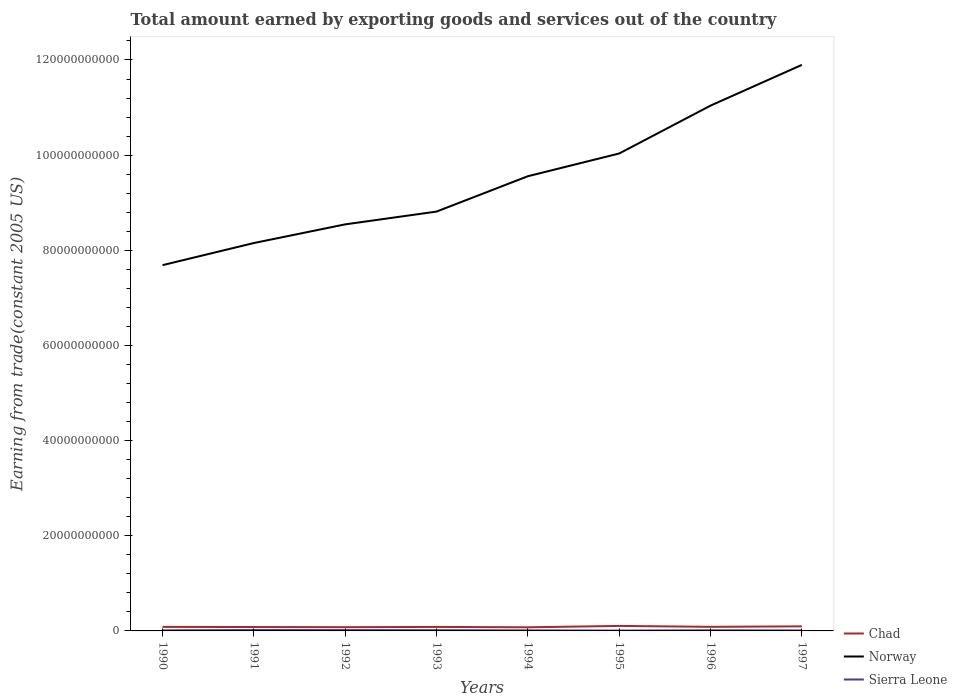Does the line corresponding to Sierra Leone intersect with the line corresponding to Chad?
Provide a short and direct response. No. Across all years, what is the maximum total amount earned by exporting goods and services in Sierra Leone?
Your answer should be compact. 7.47e+07. In which year was the total amount earned by exporting goods and services in Norway maximum?
Ensure brevity in your answer.  1990. What is the total total amount earned by exporting goods and services in Sierra Leone in the graph?
Provide a short and direct response. 5.59e+07. What is the difference between the highest and the second highest total amount earned by exporting goods and services in Sierra Leone?
Your answer should be compact. 1.14e+08. Is the total amount earned by exporting goods and services in Sierra Leone strictly greater than the total amount earned by exporting goods and services in Chad over the years?
Provide a succinct answer. Yes. How many lines are there?
Offer a very short reply. 3. How many years are there in the graph?
Make the answer very short. 8. Does the graph contain any zero values?
Your answer should be very brief. No. Does the graph contain grids?
Provide a short and direct response. No. How are the legend labels stacked?
Your answer should be very brief. Vertical. What is the title of the graph?
Make the answer very short. Total amount earned by exporting goods and services out of the country. What is the label or title of the Y-axis?
Provide a short and direct response. Earning from trade(constant 2005 US). What is the Earning from trade(constant 2005 US) of Chad in 1990?
Ensure brevity in your answer.  8.47e+08. What is the Earning from trade(constant 2005 US) of Norway in 1990?
Keep it short and to the point. 7.69e+1. What is the Earning from trade(constant 2005 US) of Sierra Leone in 1990?
Your answer should be compact. 1.25e+08. What is the Earning from trade(constant 2005 US) in Chad in 1991?
Your response must be concise. 8.17e+08. What is the Earning from trade(constant 2005 US) of Norway in 1991?
Your answer should be very brief. 8.15e+1. What is the Earning from trade(constant 2005 US) in Sierra Leone in 1991?
Make the answer very short. 1.88e+08. What is the Earning from trade(constant 2005 US) of Chad in 1992?
Your response must be concise. 7.85e+08. What is the Earning from trade(constant 2005 US) of Norway in 1992?
Offer a terse response. 8.54e+1. What is the Earning from trade(constant 2005 US) of Sierra Leone in 1992?
Ensure brevity in your answer.  1.77e+08. What is the Earning from trade(constant 2005 US) in Chad in 1993?
Your answer should be compact. 8.40e+08. What is the Earning from trade(constant 2005 US) of Norway in 1993?
Give a very brief answer. 8.81e+1. What is the Earning from trade(constant 2005 US) in Sierra Leone in 1993?
Your response must be concise. 1.53e+08. What is the Earning from trade(constant 2005 US) in Chad in 1994?
Keep it short and to the point. 7.63e+08. What is the Earning from trade(constant 2005 US) of Norway in 1994?
Make the answer very short. 9.56e+1. What is the Earning from trade(constant 2005 US) of Sierra Leone in 1994?
Keep it short and to the point. 1.17e+08. What is the Earning from trade(constant 2005 US) of Chad in 1995?
Give a very brief answer. 1.05e+09. What is the Earning from trade(constant 2005 US) of Norway in 1995?
Offer a terse response. 1.00e+11. What is the Earning from trade(constant 2005 US) of Sierra Leone in 1995?
Offer a terse response. 7.47e+07. What is the Earning from trade(constant 2005 US) in Chad in 1996?
Keep it short and to the point. 8.60e+08. What is the Earning from trade(constant 2005 US) of Norway in 1996?
Your response must be concise. 1.10e+11. What is the Earning from trade(constant 2005 US) of Sierra Leone in 1996?
Ensure brevity in your answer.  1.32e+08. What is the Earning from trade(constant 2005 US) of Chad in 1997?
Offer a terse response. 9.61e+08. What is the Earning from trade(constant 2005 US) of Norway in 1997?
Provide a short and direct response. 1.19e+11. What is the Earning from trade(constant 2005 US) in Sierra Leone in 1997?
Ensure brevity in your answer.  9.75e+07. Across all years, what is the maximum Earning from trade(constant 2005 US) of Chad?
Make the answer very short. 1.05e+09. Across all years, what is the maximum Earning from trade(constant 2005 US) of Norway?
Provide a succinct answer. 1.19e+11. Across all years, what is the maximum Earning from trade(constant 2005 US) in Sierra Leone?
Keep it short and to the point. 1.88e+08. Across all years, what is the minimum Earning from trade(constant 2005 US) in Chad?
Offer a very short reply. 7.63e+08. Across all years, what is the minimum Earning from trade(constant 2005 US) in Norway?
Offer a very short reply. 7.69e+1. Across all years, what is the minimum Earning from trade(constant 2005 US) in Sierra Leone?
Offer a very short reply. 7.47e+07. What is the total Earning from trade(constant 2005 US) in Chad in the graph?
Your answer should be very brief. 6.92e+09. What is the total Earning from trade(constant 2005 US) of Norway in the graph?
Your answer should be compact. 7.57e+11. What is the total Earning from trade(constant 2005 US) of Sierra Leone in the graph?
Keep it short and to the point. 1.06e+09. What is the difference between the Earning from trade(constant 2005 US) of Chad in 1990 and that in 1991?
Your answer should be very brief. 3.00e+07. What is the difference between the Earning from trade(constant 2005 US) in Norway in 1990 and that in 1991?
Ensure brevity in your answer.  -4.65e+09. What is the difference between the Earning from trade(constant 2005 US) in Sierra Leone in 1990 and that in 1991?
Offer a terse response. -6.33e+07. What is the difference between the Earning from trade(constant 2005 US) of Chad in 1990 and that in 1992?
Your answer should be compact. 6.13e+07. What is the difference between the Earning from trade(constant 2005 US) in Norway in 1990 and that in 1992?
Your response must be concise. -8.57e+09. What is the difference between the Earning from trade(constant 2005 US) of Sierra Leone in 1990 and that in 1992?
Make the answer very short. -5.21e+07. What is the difference between the Earning from trade(constant 2005 US) in Chad in 1990 and that in 1993?
Offer a very short reply. 7.17e+06. What is the difference between the Earning from trade(constant 2005 US) of Norway in 1990 and that in 1993?
Keep it short and to the point. -1.13e+1. What is the difference between the Earning from trade(constant 2005 US) of Sierra Leone in 1990 and that in 1993?
Your answer should be very brief. -2.84e+07. What is the difference between the Earning from trade(constant 2005 US) in Chad in 1990 and that in 1994?
Ensure brevity in your answer.  8.37e+07. What is the difference between the Earning from trade(constant 2005 US) in Norway in 1990 and that in 1994?
Offer a terse response. -1.87e+1. What is the difference between the Earning from trade(constant 2005 US) in Sierra Leone in 1990 and that in 1994?
Offer a very short reply. 8.15e+06. What is the difference between the Earning from trade(constant 2005 US) of Chad in 1990 and that in 1995?
Your answer should be very brief. -2.05e+08. What is the difference between the Earning from trade(constant 2005 US) in Norway in 1990 and that in 1995?
Offer a terse response. -2.35e+1. What is the difference between the Earning from trade(constant 2005 US) of Sierra Leone in 1990 and that in 1995?
Ensure brevity in your answer.  5.03e+07. What is the difference between the Earning from trade(constant 2005 US) of Chad in 1990 and that in 1996?
Your answer should be very brief. -1.34e+07. What is the difference between the Earning from trade(constant 2005 US) of Norway in 1990 and that in 1996?
Offer a very short reply. -3.35e+1. What is the difference between the Earning from trade(constant 2005 US) of Sierra Leone in 1990 and that in 1996?
Your answer should be compact. -6.70e+06. What is the difference between the Earning from trade(constant 2005 US) of Chad in 1990 and that in 1997?
Give a very brief answer. -1.14e+08. What is the difference between the Earning from trade(constant 2005 US) of Norway in 1990 and that in 1997?
Give a very brief answer. -4.21e+1. What is the difference between the Earning from trade(constant 2005 US) of Sierra Leone in 1990 and that in 1997?
Your answer should be very brief. 2.75e+07. What is the difference between the Earning from trade(constant 2005 US) of Chad in 1991 and that in 1992?
Provide a short and direct response. 3.13e+07. What is the difference between the Earning from trade(constant 2005 US) in Norway in 1991 and that in 1992?
Provide a succinct answer. -3.92e+09. What is the difference between the Earning from trade(constant 2005 US) in Sierra Leone in 1991 and that in 1992?
Make the answer very short. 1.12e+07. What is the difference between the Earning from trade(constant 2005 US) of Chad in 1991 and that in 1993?
Give a very brief answer. -2.28e+07. What is the difference between the Earning from trade(constant 2005 US) in Norway in 1991 and that in 1993?
Ensure brevity in your answer.  -6.61e+09. What is the difference between the Earning from trade(constant 2005 US) of Sierra Leone in 1991 and that in 1993?
Provide a succinct answer. 3.49e+07. What is the difference between the Earning from trade(constant 2005 US) of Chad in 1991 and that in 1994?
Keep it short and to the point. 5.37e+07. What is the difference between the Earning from trade(constant 2005 US) of Norway in 1991 and that in 1994?
Offer a very short reply. -1.40e+1. What is the difference between the Earning from trade(constant 2005 US) of Sierra Leone in 1991 and that in 1994?
Offer a very short reply. 7.15e+07. What is the difference between the Earning from trade(constant 2005 US) in Chad in 1991 and that in 1995?
Offer a terse response. -2.35e+08. What is the difference between the Earning from trade(constant 2005 US) of Norway in 1991 and that in 1995?
Provide a succinct answer. -1.88e+1. What is the difference between the Earning from trade(constant 2005 US) of Sierra Leone in 1991 and that in 1995?
Give a very brief answer. 1.14e+08. What is the difference between the Earning from trade(constant 2005 US) of Chad in 1991 and that in 1996?
Your answer should be very brief. -4.34e+07. What is the difference between the Earning from trade(constant 2005 US) of Norway in 1991 and that in 1996?
Your answer should be very brief. -2.89e+1. What is the difference between the Earning from trade(constant 2005 US) in Sierra Leone in 1991 and that in 1996?
Your response must be concise. 5.66e+07. What is the difference between the Earning from trade(constant 2005 US) in Chad in 1991 and that in 1997?
Offer a terse response. -1.44e+08. What is the difference between the Earning from trade(constant 2005 US) in Norway in 1991 and that in 1997?
Your answer should be very brief. -3.74e+1. What is the difference between the Earning from trade(constant 2005 US) of Sierra Leone in 1991 and that in 1997?
Give a very brief answer. 9.08e+07. What is the difference between the Earning from trade(constant 2005 US) of Chad in 1992 and that in 1993?
Keep it short and to the point. -5.41e+07. What is the difference between the Earning from trade(constant 2005 US) of Norway in 1992 and that in 1993?
Offer a terse response. -2.69e+09. What is the difference between the Earning from trade(constant 2005 US) of Sierra Leone in 1992 and that in 1993?
Give a very brief answer. 2.37e+07. What is the difference between the Earning from trade(constant 2005 US) of Chad in 1992 and that in 1994?
Offer a terse response. 2.24e+07. What is the difference between the Earning from trade(constant 2005 US) of Norway in 1992 and that in 1994?
Keep it short and to the point. -1.01e+1. What is the difference between the Earning from trade(constant 2005 US) in Sierra Leone in 1992 and that in 1994?
Give a very brief answer. 6.02e+07. What is the difference between the Earning from trade(constant 2005 US) in Chad in 1992 and that in 1995?
Offer a very short reply. -2.66e+08. What is the difference between the Earning from trade(constant 2005 US) of Norway in 1992 and that in 1995?
Your response must be concise. -1.49e+1. What is the difference between the Earning from trade(constant 2005 US) of Sierra Leone in 1992 and that in 1995?
Give a very brief answer. 1.02e+08. What is the difference between the Earning from trade(constant 2005 US) in Chad in 1992 and that in 1996?
Provide a succinct answer. -7.46e+07. What is the difference between the Earning from trade(constant 2005 US) in Norway in 1992 and that in 1996?
Make the answer very short. -2.50e+1. What is the difference between the Earning from trade(constant 2005 US) in Sierra Leone in 1992 and that in 1996?
Keep it short and to the point. 4.54e+07. What is the difference between the Earning from trade(constant 2005 US) in Chad in 1992 and that in 1997?
Provide a succinct answer. -1.75e+08. What is the difference between the Earning from trade(constant 2005 US) of Norway in 1992 and that in 1997?
Offer a very short reply. -3.35e+1. What is the difference between the Earning from trade(constant 2005 US) of Sierra Leone in 1992 and that in 1997?
Your answer should be compact. 7.95e+07. What is the difference between the Earning from trade(constant 2005 US) in Chad in 1993 and that in 1994?
Provide a succinct answer. 7.65e+07. What is the difference between the Earning from trade(constant 2005 US) of Norway in 1993 and that in 1994?
Offer a terse response. -7.43e+09. What is the difference between the Earning from trade(constant 2005 US) in Sierra Leone in 1993 and that in 1994?
Provide a succinct answer. 3.65e+07. What is the difference between the Earning from trade(constant 2005 US) of Chad in 1993 and that in 1995?
Your response must be concise. -2.12e+08. What is the difference between the Earning from trade(constant 2005 US) in Norway in 1993 and that in 1995?
Your answer should be very brief. -1.22e+1. What is the difference between the Earning from trade(constant 2005 US) in Sierra Leone in 1993 and that in 1995?
Ensure brevity in your answer.  7.87e+07. What is the difference between the Earning from trade(constant 2005 US) in Chad in 1993 and that in 1996?
Your response must be concise. -2.05e+07. What is the difference between the Earning from trade(constant 2005 US) of Norway in 1993 and that in 1996?
Offer a terse response. -2.23e+1. What is the difference between the Earning from trade(constant 2005 US) in Sierra Leone in 1993 and that in 1996?
Your answer should be compact. 2.17e+07. What is the difference between the Earning from trade(constant 2005 US) of Chad in 1993 and that in 1997?
Offer a very short reply. -1.21e+08. What is the difference between the Earning from trade(constant 2005 US) of Norway in 1993 and that in 1997?
Your answer should be compact. -3.08e+1. What is the difference between the Earning from trade(constant 2005 US) of Sierra Leone in 1993 and that in 1997?
Your answer should be compact. 5.59e+07. What is the difference between the Earning from trade(constant 2005 US) of Chad in 1994 and that in 1995?
Keep it short and to the point. -2.89e+08. What is the difference between the Earning from trade(constant 2005 US) in Norway in 1994 and that in 1995?
Your answer should be very brief. -4.78e+09. What is the difference between the Earning from trade(constant 2005 US) of Sierra Leone in 1994 and that in 1995?
Your answer should be compact. 4.22e+07. What is the difference between the Earning from trade(constant 2005 US) of Chad in 1994 and that in 1996?
Your answer should be very brief. -9.70e+07. What is the difference between the Earning from trade(constant 2005 US) in Norway in 1994 and that in 1996?
Your response must be concise. -1.48e+1. What is the difference between the Earning from trade(constant 2005 US) in Sierra Leone in 1994 and that in 1996?
Provide a short and direct response. -1.48e+07. What is the difference between the Earning from trade(constant 2005 US) in Chad in 1994 and that in 1997?
Make the answer very short. -1.97e+08. What is the difference between the Earning from trade(constant 2005 US) of Norway in 1994 and that in 1997?
Your answer should be compact. -2.34e+1. What is the difference between the Earning from trade(constant 2005 US) of Sierra Leone in 1994 and that in 1997?
Offer a very short reply. 1.93e+07. What is the difference between the Earning from trade(constant 2005 US) of Chad in 1995 and that in 1996?
Provide a short and direct response. 1.92e+08. What is the difference between the Earning from trade(constant 2005 US) in Norway in 1995 and that in 1996?
Keep it short and to the point. -1.01e+1. What is the difference between the Earning from trade(constant 2005 US) of Sierra Leone in 1995 and that in 1996?
Keep it short and to the point. -5.70e+07. What is the difference between the Earning from trade(constant 2005 US) of Chad in 1995 and that in 1997?
Give a very brief answer. 9.13e+07. What is the difference between the Earning from trade(constant 2005 US) in Norway in 1995 and that in 1997?
Your answer should be compact. -1.86e+1. What is the difference between the Earning from trade(constant 2005 US) of Sierra Leone in 1995 and that in 1997?
Keep it short and to the point. -2.29e+07. What is the difference between the Earning from trade(constant 2005 US) in Chad in 1996 and that in 1997?
Keep it short and to the point. -1.00e+08. What is the difference between the Earning from trade(constant 2005 US) in Norway in 1996 and that in 1997?
Keep it short and to the point. -8.57e+09. What is the difference between the Earning from trade(constant 2005 US) of Sierra Leone in 1996 and that in 1997?
Your answer should be very brief. 3.42e+07. What is the difference between the Earning from trade(constant 2005 US) in Chad in 1990 and the Earning from trade(constant 2005 US) in Norway in 1991?
Provide a short and direct response. -8.07e+1. What is the difference between the Earning from trade(constant 2005 US) in Chad in 1990 and the Earning from trade(constant 2005 US) in Sierra Leone in 1991?
Ensure brevity in your answer.  6.58e+08. What is the difference between the Earning from trade(constant 2005 US) of Norway in 1990 and the Earning from trade(constant 2005 US) of Sierra Leone in 1991?
Ensure brevity in your answer.  7.67e+1. What is the difference between the Earning from trade(constant 2005 US) of Chad in 1990 and the Earning from trade(constant 2005 US) of Norway in 1992?
Your answer should be compact. -8.46e+1. What is the difference between the Earning from trade(constant 2005 US) in Chad in 1990 and the Earning from trade(constant 2005 US) in Sierra Leone in 1992?
Provide a short and direct response. 6.70e+08. What is the difference between the Earning from trade(constant 2005 US) in Norway in 1990 and the Earning from trade(constant 2005 US) in Sierra Leone in 1992?
Give a very brief answer. 7.67e+1. What is the difference between the Earning from trade(constant 2005 US) of Chad in 1990 and the Earning from trade(constant 2005 US) of Norway in 1993?
Your response must be concise. -8.73e+1. What is the difference between the Earning from trade(constant 2005 US) in Chad in 1990 and the Earning from trade(constant 2005 US) in Sierra Leone in 1993?
Your answer should be compact. 6.93e+08. What is the difference between the Earning from trade(constant 2005 US) of Norway in 1990 and the Earning from trade(constant 2005 US) of Sierra Leone in 1993?
Your answer should be compact. 7.67e+1. What is the difference between the Earning from trade(constant 2005 US) of Chad in 1990 and the Earning from trade(constant 2005 US) of Norway in 1994?
Your response must be concise. -9.47e+1. What is the difference between the Earning from trade(constant 2005 US) of Chad in 1990 and the Earning from trade(constant 2005 US) of Sierra Leone in 1994?
Keep it short and to the point. 7.30e+08. What is the difference between the Earning from trade(constant 2005 US) of Norway in 1990 and the Earning from trade(constant 2005 US) of Sierra Leone in 1994?
Offer a very short reply. 7.68e+1. What is the difference between the Earning from trade(constant 2005 US) of Chad in 1990 and the Earning from trade(constant 2005 US) of Norway in 1995?
Ensure brevity in your answer.  -9.95e+1. What is the difference between the Earning from trade(constant 2005 US) in Chad in 1990 and the Earning from trade(constant 2005 US) in Sierra Leone in 1995?
Offer a terse response. 7.72e+08. What is the difference between the Earning from trade(constant 2005 US) of Norway in 1990 and the Earning from trade(constant 2005 US) of Sierra Leone in 1995?
Your answer should be very brief. 7.68e+1. What is the difference between the Earning from trade(constant 2005 US) in Chad in 1990 and the Earning from trade(constant 2005 US) in Norway in 1996?
Your response must be concise. -1.10e+11. What is the difference between the Earning from trade(constant 2005 US) in Chad in 1990 and the Earning from trade(constant 2005 US) in Sierra Leone in 1996?
Keep it short and to the point. 7.15e+08. What is the difference between the Earning from trade(constant 2005 US) in Norway in 1990 and the Earning from trade(constant 2005 US) in Sierra Leone in 1996?
Offer a terse response. 7.67e+1. What is the difference between the Earning from trade(constant 2005 US) of Chad in 1990 and the Earning from trade(constant 2005 US) of Norway in 1997?
Provide a short and direct response. -1.18e+11. What is the difference between the Earning from trade(constant 2005 US) in Chad in 1990 and the Earning from trade(constant 2005 US) in Sierra Leone in 1997?
Keep it short and to the point. 7.49e+08. What is the difference between the Earning from trade(constant 2005 US) in Norway in 1990 and the Earning from trade(constant 2005 US) in Sierra Leone in 1997?
Ensure brevity in your answer.  7.68e+1. What is the difference between the Earning from trade(constant 2005 US) in Chad in 1991 and the Earning from trade(constant 2005 US) in Norway in 1992?
Provide a short and direct response. -8.46e+1. What is the difference between the Earning from trade(constant 2005 US) of Chad in 1991 and the Earning from trade(constant 2005 US) of Sierra Leone in 1992?
Keep it short and to the point. 6.40e+08. What is the difference between the Earning from trade(constant 2005 US) in Norway in 1991 and the Earning from trade(constant 2005 US) in Sierra Leone in 1992?
Provide a succinct answer. 8.13e+1. What is the difference between the Earning from trade(constant 2005 US) of Chad in 1991 and the Earning from trade(constant 2005 US) of Norway in 1993?
Your answer should be very brief. -8.73e+1. What is the difference between the Earning from trade(constant 2005 US) in Chad in 1991 and the Earning from trade(constant 2005 US) in Sierra Leone in 1993?
Your response must be concise. 6.63e+08. What is the difference between the Earning from trade(constant 2005 US) in Norway in 1991 and the Earning from trade(constant 2005 US) in Sierra Leone in 1993?
Make the answer very short. 8.14e+1. What is the difference between the Earning from trade(constant 2005 US) in Chad in 1991 and the Earning from trade(constant 2005 US) in Norway in 1994?
Offer a very short reply. -9.48e+1. What is the difference between the Earning from trade(constant 2005 US) of Chad in 1991 and the Earning from trade(constant 2005 US) of Sierra Leone in 1994?
Offer a very short reply. 7.00e+08. What is the difference between the Earning from trade(constant 2005 US) in Norway in 1991 and the Earning from trade(constant 2005 US) in Sierra Leone in 1994?
Offer a terse response. 8.14e+1. What is the difference between the Earning from trade(constant 2005 US) of Chad in 1991 and the Earning from trade(constant 2005 US) of Norway in 1995?
Ensure brevity in your answer.  -9.95e+1. What is the difference between the Earning from trade(constant 2005 US) in Chad in 1991 and the Earning from trade(constant 2005 US) in Sierra Leone in 1995?
Provide a succinct answer. 7.42e+08. What is the difference between the Earning from trade(constant 2005 US) of Norway in 1991 and the Earning from trade(constant 2005 US) of Sierra Leone in 1995?
Make the answer very short. 8.15e+1. What is the difference between the Earning from trade(constant 2005 US) of Chad in 1991 and the Earning from trade(constant 2005 US) of Norway in 1996?
Ensure brevity in your answer.  -1.10e+11. What is the difference between the Earning from trade(constant 2005 US) in Chad in 1991 and the Earning from trade(constant 2005 US) in Sierra Leone in 1996?
Your response must be concise. 6.85e+08. What is the difference between the Earning from trade(constant 2005 US) of Norway in 1991 and the Earning from trade(constant 2005 US) of Sierra Leone in 1996?
Your answer should be very brief. 8.14e+1. What is the difference between the Earning from trade(constant 2005 US) of Chad in 1991 and the Earning from trade(constant 2005 US) of Norway in 1997?
Make the answer very short. -1.18e+11. What is the difference between the Earning from trade(constant 2005 US) in Chad in 1991 and the Earning from trade(constant 2005 US) in Sierra Leone in 1997?
Give a very brief answer. 7.19e+08. What is the difference between the Earning from trade(constant 2005 US) of Norway in 1991 and the Earning from trade(constant 2005 US) of Sierra Leone in 1997?
Offer a terse response. 8.14e+1. What is the difference between the Earning from trade(constant 2005 US) of Chad in 1992 and the Earning from trade(constant 2005 US) of Norway in 1993?
Your answer should be compact. -8.74e+1. What is the difference between the Earning from trade(constant 2005 US) in Chad in 1992 and the Earning from trade(constant 2005 US) in Sierra Leone in 1993?
Your answer should be very brief. 6.32e+08. What is the difference between the Earning from trade(constant 2005 US) of Norway in 1992 and the Earning from trade(constant 2005 US) of Sierra Leone in 1993?
Your answer should be compact. 8.53e+1. What is the difference between the Earning from trade(constant 2005 US) in Chad in 1992 and the Earning from trade(constant 2005 US) in Norway in 1994?
Your response must be concise. -9.48e+1. What is the difference between the Earning from trade(constant 2005 US) in Chad in 1992 and the Earning from trade(constant 2005 US) in Sierra Leone in 1994?
Keep it short and to the point. 6.69e+08. What is the difference between the Earning from trade(constant 2005 US) in Norway in 1992 and the Earning from trade(constant 2005 US) in Sierra Leone in 1994?
Offer a terse response. 8.53e+1. What is the difference between the Earning from trade(constant 2005 US) of Chad in 1992 and the Earning from trade(constant 2005 US) of Norway in 1995?
Make the answer very short. -9.96e+1. What is the difference between the Earning from trade(constant 2005 US) in Chad in 1992 and the Earning from trade(constant 2005 US) in Sierra Leone in 1995?
Offer a terse response. 7.11e+08. What is the difference between the Earning from trade(constant 2005 US) in Norway in 1992 and the Earning from trade(constant 2005 US) in Sierra Leone in 1995?
Your response must be concise. 8.54e+1. What is the difference between the Earning from trade(constant 2005 US) in Chad in 1992 and the Earning from trade(constant 2005 US) in Norway in 1996?
Provide a succinct answer. -1.10e+11. What is the difference between the Earning from trade(constant 2005 US) of Chad in 1992 and the Earning from trade(constant 2005 US) of Sierra Leone in 1996?
Provide a succinct answer. 6.54e+08. What is the difference between the Earning from trade(constant 2005 US) in Norway in 1992 and the Earning from trade(constant 2005 US) in Sierra Leone in 1996?
Make the answer very short. 8.53e+1. What is the difference between the Earning from trade(constant 2005 US) of Chad in 1992 and the Earning from trade(constant 2005 US) of Norway in 1997?
Offer a terse response. -1.18e+11. What is the difference between the Earning from trade(constant 2005 US) of Chad in 1992 and the Earning from trade(constant 2005 US) of Sierra Leone in 1997?
Provide a succinct answer. 6.88e+08. What is the difference between the Earning from trade(constant 2005 US) of Norway in 1992 and the Earning from trade(constant 2005 US) of Sierra Leone in 1997?
Your answer should be very brief. 8.54e+1. What is the difference between the Earning from trade(constant 2005 US) in Chad in 1993 and the Earning from trade(constant 2005 US) in Norway in 1994?
Give a very brief answer. -9.47e+1. What is the difference between the Earning from trade(constant 2005 US) of Chad in 1993 and the Earning from trade(constant 2005 US) of Sierra Leone in 1994?
Provide a succinct answer. 7.23e+08. What is the difference between the Earning from trade(constant 2005 US) in Norway in 1993 and the Earning from trade(constant 2005 US) in Sierra Leone in 1994?
Offer a terse response. 8.80e+1. What is the difference between the Earning from trade(constant 2005 US) in Chad in 1993 and the Earning from trade(constant 2005 US) in Norway in 1995?
Offer a very short reply. -9.95e+1. What is the difference between the Earning from trade(constant 2005 US) of Chad in 1993 and the Earning from trade(constant 2005 US) of Sierra Leone in 1995?
Make the answer very short. 7.65e+08. What is the difference between the Earning from trade(constant 2005 US) in Norway in 1993 and the Earning from trade(constant 2005 US) in Sierra Leone in 1995?
Keep it short and to the point. 8.81e+1. What is the difference between the Earning from trade(constant 2005 US) in Chad in 1993 and the Earning from trade(constant 2005 US) in Norway in 1996?
Give a very brief answer. -1.10e+11. What is the difference between the Earning from trade(constant 2005 US) of Chad in 1993 and the Earning from trade(constant 2005 US) of Sierra Leone in 1996?
Your response must be concise. 7.08e+08. What is the difference between the Earning from trade(constant 2005 US) of Norway in 1993 and the Earning from trade(constant 2005 US) of Sierra Leone in 1996?
Make the answer very short. 8.80e+1. What is the difference between the Earning from trade(constant 2005 US) in Chad in 1993 and the Earning from trade(constant 2005 US) in Norway in 1997?
Give a very brief answer. -1.18e+11. What is the difference between the Earning from trade(constant 2005 US) in Chad in 1993 and the Earning from trade(constant 2005 US) in Sierra Leone in 1997?
Your answer should be very brief. 7.42e+08. What is the difference between the Earning from trade(constant 2005 US) in Norway in 1993 and the Earning from trade(constant 2005 US) in Sierra Leone in 1997?
Offer a very short reply. 8.80e+1. What is the difference between the Earning from trade(constant 2005 US) of Chad in 1994 and the Earning from trade(constant 2005 US) of Norway in 1995?
Provide a succinct answer. -9.96e+1. What is the difference between the Earning from trade(constant 2005 US) of Chad in 1994 and the Earning from trade(constant 2005 US) of Sierra Leone in 1995?
Your answer should be compact. 6.88e+08. What is the difference between the Earning from trade(constant 2005 US) of Norway in 1994 and the Earning from trade(constant 2005 US) of Sierra Leone in 1995?
Keep it short and to the point. 9.55e+1. What is the difference between the Earning from trade(constant 2005 US) in Chad in 1994 and the Earning from trade(constant 2005 US) in Norway in 1996?
Make the answer very short. -1.10e+11. What is the difference between the Earning from trade(constant 2005 US) in Chad in 1994 and the Earning from trade(constant 2005 US) in Sierra Leone in 1996?
Offer a terse response. 6.31e+08. What is the difference between the Earning from trade(constant 2005 US) of Norway in 1994 and the Earning from trade(constant 2005 US) of Sierra Leone in 1996?
Ensure brevity in your answer.  9.54e+1. What is the difference between the Earning from trade(constant 2005 US) in Chad in 1994 and the Earning from trade(constant 2005 US) in Norway in 1997?
Make the answer very short. -1.18e+11. What is the difference between the Earning from trade(constant 2005 US) of Chad in 1994 and the Earning from trade(constant 2005 US) of Sierra Leone in 1997?
Make the answer very short. 6.66e+08. What is the difference between the Earning from trade(constant 2005 US) of Norway in 1994 and the Earning from trade(constant 2005 US) of Sierra Leone in 1997?
Your answer should be compact. 9.55e+1. What is the difference between the Earning from trade(constant 2005 US) of Chad in 1995 and the Earning from trade(constant 2005 US) of Norway in 1996?
Give a very brief answer. -1.09e+11. What is the difference between the Earning from trade(constant 2005 US) in Chad in 1995 and the Earning from trade(constant 2005 US) in Sierra Leone in 1996?
Offer a terse response. 9.20e+08. What is the difference between the Earning from trade(constant 2005 US) of Norway in 1995 and the Earning from trade(constant 2005 US) of Sierra Leone in 1996?
Provide a succinct answer. 1.00e+11. What is the difference between the Earning from trade(constant 2005 US) of Chad in 1995 and the Earning from trade(constant 2005 US) of Norway in 1997?
Your response must be concise. -1.18e+11. What is the difference between the Earning from trade(constant 2005 US) in Chad in 1995 and the Earning from trade(constant 2005 US) in Sierra Leone in 1997?
Give a very brief answer. 9.54e+08. What is the difference between the Earning from trade(constant 2005 US) in Norway in 1995 and the Earning from trade(constant 2005 US) in Sierra Leone in 1997?
Your answer should be compact. 1.00e+11. What is the difference between the Earning from trade(constant 2005 US) in Chad in 1996 and the Earning from trade(constant 2005 US) in Norway in 1997?
Keep it short and to the point. -1.18e+11. What is the difference between the Earning from trade(constant 2005 US) in Chad in 1996 and the Earning from trade(constant 2005 US) in Sierra Leone in 1997?
Keep it short and to the point. 7.63e+08. What is the difference between the Earning from trade(constant 2005 US) of Norway in 1996 and the Earning from trade(constant 2005 US) of Sierra Leone in 1997?
Give a very brief answer. 1.10e+11. What is the average Earning from trade(constant 2005 US) in Chad per year?
Provide a short and direct response. 8.66e+08. What is the average Earning from trade(constant 2005 US) of Norway per year?
Ensure brevity in your answer.  9.47e+1. What is the average Earning from trade(constant 2005 US) of Sierra Leone per year?
Your response must be concise. 1.33e+08. In the year 1990, what is the difference between the Earning from trade(constant 2005 US) in Chad and Earning from trade(constant 2005 US) in Norway?
Your answer should be compact. -7.60e+1. In the year 1990, what is the difference between the Earning from trade(constant 2005 US) of Chad and Earning from trade(constant 2005 US) of Sierra Leone?
Give a very brief answer. 7.22e+08. In the year 1990, what is the difference between the Earning from trade(constant 2005 US) of Norway and Earning from trade(constant 2005 US) of Sierra Leone?
Keep it short and to the point. 7.68e+1. In the year 1991, what is the difference between the Earning from trade(constant 2005 US) in Chad and Earning from trade(constant 2005 US) in Norway?
Make the answer very short. -8.07e+1. In the year 1991, what is the difference between the Earning from trade(constant 2005 US) of Chad and Earning from trade(constant 2005 US) of Sierra Leone?
Make the answer very short. 6.28e+08. In the year 1991, what is the difference between the Earning from trade(constant 2005 US) of Norway and Earning from trade(constant 2005 US) of Sierra Leone?
Provide a succinct answer. 8.13e+1. In the year 1992, what is the difference between the Earning from trade(constant 2005 US) of Chad and Earning from trade(constant 2005 US) of Norway?
Offer a terse response. -8.47e+1. In the year 1992, what is the difference between the Earning from trade(constant 2005 US) of Chad and Earning from trade(constant 2005 US) of Sierra Leone?
Make the answer very short. 6.08e+08. In the year 1992, what is the difference between the Earning from trade(constant 2005 US) in Norway and Earning from trade(constant 2005 US) in Sierra Leone?
Make the answer very short. 8.53e+1. In the year 1993, what is the difference between the Earning from trade(constant 2005 US) in Chad and Earning from trade(constant 2005 US) in Norway?
Give a very brief answer. -8.73e+1. In the year 1993, what is the difference between the Earning from trade(constant 2005 US) in Chad and Earning from trade(constant 2005 US) in Sierra Leone?
Your answer should be very brief. 6.86e+08. In the year 1993, what is the difference between the Earning from trade(constant 2005 US) of Norway and Earning from trade(constant 2005 US) of Sierra Leone?
Give a very brief answer. 8.80e+1. In the year 1994, what is the difference between the Earning from trade(constant 2005 US) in Chad and Earning from trade(constant 2005 US) in Norway?
Give a very brief answer. -9.48e+1. In the year 1994, what is the difference between the Earning from trade(constant 2005 US) of Chad and Earning from trade(constant 2005 US) of Sierra Leone?
Keep it short and to the point. 6.46e+08. In the year 1994, what is the difference between the Earning from trade(constant 2005 US) in Norway and Earning from trade(constant 2005 US) in Sierra Leone?
Give a very brief answer. 9.55e+1. In the year 1995, what is the difference between the Earning from trade(constant 2005 US) in Chad and Earning from trade(constant 2005 US) in Norway?
Provide a short and direct response. -9.93e+1. In the year 1995, what is the difference between the Earning from trade(constant 2005 US) of Chad and Earning from trade(constant 2005 US) of Sierra Leone?
Offer a terse response. 9.77e+08. In the year 1995, what is the difference between the Earning from trade(constant 2005 US) of Norway and Earning from trade(constant 2005 US) of Sierra Leone?
Offer a terse response. 1.00e+11. In the year 1996, what is the difference between the Earning from trade(constant 2005 US) in Chad and Earning from trade(constant 2005 US) in Norway?
Offer a terse response. -1.10e+11. In the year 1996, what is the difference between the Earning from trade(constant 2005 US) in Chad and Earning from trade(constant 2005 US) in Sierra Leone?
Make the answer very short. 7.28e+08. In the year 1996, what is the difference between the Earning from trade(constant 2005 US) of Norway and Earning from trade(constant 2005 US) of Sierra Leone?
Your answer should be compact. 1.10e+11. In the year 1997, what is the difference between the Earning from trade(constant 2005 US) of Chad and Earning from trade(constant 2005 US) of Norway?
Provide a succinct answer. -1.18e+11. In the year 1997, what is the difference between the Earning from trade(constant 2005 US) of Chad and Earning from trade(constant 2005 US) of Sierra Leone?
Give a very brief answer. 8.63e+08. In the year 1997, what is the difference between the Earning from trade(constant 2005 US) of Norway and Earning from trade(constant 2005 US) of Sierra Leone?
Your answer should be very brief. 1.19e+11. What is the ratio of the Earning from trade(constant 2005 US) in Chad in 1990 to that in 1991?
Make the answer very short. 1.04. What is the ratio of the Earning from trade(constant 2005 US) of Norway in 1990 to that in 1991?
Your answer should be very brief. 0.94. What is the ratio of the Earning from trade(constant 2005 US) of Sierra Leone in 1990 to that in 1991?
Make the answer very short. 0.66. What is the ratio of the Earning from trade(constant 2005 US) of Chad in 1990 to that in 1992?
Provide a short and direct response. 1.08. What is the ratio of the Earning from trade(constant 2005 US) in Norway in 1990 to that in 1992?
Provide a short and direct response. 0.9. What is the ratio of the Earning from trade(constant 2005 US) of Sierra Leone in 1990 to that in 1992?
Make the answer very short. 0.71. What is the ratio of the Earning from trade(constant 2005 US) of Chad in 1990 to that in 1993?
Your answer should be compact. 1.01. What is the ratio of the Earning from trade(constant 2005 US) in Norway in 1990 to that in 1993?
Provide a succinct answer. 0.87. What is the ratio of the Earning from trade(constant 2005 US) of Sierra Leone in 1990 to that in 1993?
Offer a very short reply. 0.81. What is the ratio of the Earning from trade(constant 2005 US) in Chad in 1990 to that in 1994?
Your answer should be compact. 1.11. What is the ratio of the Earning from trade(constant 2005 US) in Norway in 1990 to that in 1994?
Keep it short and to the point. 0.8. What is the ratio of the Earning from trade(constant 2005 US) of Sierra Leone in 1990 to that in 1994?
Keep it short and to the point. 1.07. What is the ratio of the Earning from trade(constant 2005 US) of Chad in 1990 to that in 1995?
Make the answer very short. 0.81. What is the ratio of the Earning from trade(constant 2005 US) of Norway in 1990 to that in 1995?
Ensure brevity in your answer.  0.77. What is the ratio of the Earning from trade(constant 2005 US) in Sierra Leone in 1990 to that in 1995?
Make the answer very short. 1.67. What is the ratio of the Earning from trade(constant 2005 US) in Chad in 1990 to that in 1996?
Provide a short and direct response. 0.98. What is the ratio of the Earning from trade(constant 2005 US) of Norway in 1990 to that in 1996?
Offer a very short reply. 0.7. What is the ratio of the Earning from trade(constant 2005 US) in Sierra Leone in 1990 to that in 1996?
Offer a very short reply. 0.95. What is the ratio of the Earning from trade(constant 2005 US) in Chad in 1990 to that in 1997?
Make the answer very short. 0.88. What is the ratio of the Earning from trade(constant 2005 US) of Norway in 1990 to that in 1997?
Ensure brevity in your answer.  0.65. What is the ratio of the Earning from trade(constant 2005 US) of Sierra Leone in 1990 to that in 1997?
Provide a succinct answer. 1.28. What is the ratio of the Earning from trade(constant 2005 US) in Chad in 1991 to that in 1992?
Ensure brevity in your answer.  1.04. What is the ratio of the Earning from trade(constant 2005 US) of Norway in 1991 to that in 1992?
Offer a very short reply. 0.95. What is the ratio of the Earning from trade(constant 2005 US) in Sierra Leone in 1991 to that in 1992?
Your answer should be very brief. 1.06. What is the ratio of the Earning from trade(constant 2005 US) of Chad in 1991 to that in 1993?
Your answer should be very brief. 0.97. What is the ratio of the Earning from trade(constant 2005 US) in Norway in 1991 to that in 1993?
Offer a terse response. 0.93. What is the ratio of the Earning from trade(constant 2005 US) in Sierra Leone in 1991 to that in 1993?
Ensure brevity in your answer.  1.23. What is the ratio of the Earning from trade(constant 2005 US) of Chad in 1991 to that in 1994?
Provide a short and direct response. 1.07. What is the ratio of the Earning from trade(constant 2005 US) in Norway in 1991 to that in 1994?
Ensure brevity in your answer.  0.85. What is the ratio of the Earning from trade(constant 2005 US) of Sierra Leone in 1991 to that in 1994?
Give a very brief answer. 1.61. What is the ratio of the Earning from trade(constant 2005 US) in Chad in 1991 to that in 1995?
Make the answer very short. 0.78. What is the ratio of the Earning from trade(constant 2005 US) of Norway in 1991 to that in 1995?
Your response must be concise. 0.81. What is the ratio of the Earning from trade(constant 2005 US) of Sierra Leone in 1991 to that in 1995?
Offer a terse response. 2.52. What is the ratio of the Earning from trade(constant 2005 US) in Chad in 1991 to that in 1996?
Ensure brevity in your answer.  0.95. What is the ratio of the Earning from trade(constant 2005 US) of Norway in 1991 to that in 1996?
Offer a very short reply. 0.74. What is the ratio of the Earning from trade(constant 2005 US) of Sierra Leone in 1991 to that in 1996?
Ensure brevity in your answer.  1.43. What is the ratio of the Earning from trade(constant 2005 US) of Chad in 1991 to that in 1997?
Offer a very short reply. 0.85. What is the ratio of the Earning from trade(constant 2005 US) in Norway in 1991 to that in 1997?
Offer a terse response. 0.69. What is the ratio of the Earning from trade(constant 2005 US) in Sierra Leone in 1991 to that in 1997?
Provide a short and direct response. 1.93. What is the ratio of the Earning from trade(constant 2005 US) in Chad in 1992 to that in 1993?
Your response must be concise. 0.94. What is the ratio of the Earning from trade(constant 2005 US) of Norway in 1992 to that in 1993?
Ensure brevity in your answer.  0.97. What is the ratio of the Earning from trade(constant 2005 US) in Sierra Leone in 1992 to that in 1993?
Provide a short and direct response. 1.15. What is the ratio of the Earning from trade(constant 2005 US) in Chad in 1992 to that in 1994?
Ensure brevity in your answer.  1.03. What is the ratio of the Earning from trade(constant 2005 US) in Norway in 1992 to that in 1994?
Offer a terse response. 0.89. What is the ratio of the Earning from trade(constant 2005 US) of Sierra Leone in 1992 to that in 1994?
Give a very brief answer. 1.52. What is the ratio of the Earning from trade(constant 2005 US) of Chad in 1992 to that in 1995?
Keep it short and to the point. 0.75. What is the ratio of the Earning from trade(constant 2005 US) in Norway in 1992 to that in 1995?
Your answer should be very brief. 0.85. What is the ratio of the Earning from trade(constant 2005 US) in Sierra Leone in 1992 to that in 1995?
Provide a succinct answer. 2.37. What is the ratio of the Earning from trade(constant 2005 US) of Chad in 1992 to that in 1996?
Provide a succinct answer. 0.91. What is the ratio of the Earning from trade(constant 2005 US) of Norway in 1992 to that in 1996?
Your answer should be very brief. 0.77. What is the ratio of the Earning from trade(constant 2005 US) in Sierra Leone in 1992 to that in 1996?
Keep it short and to the point. 1.34. What is the ratio of the Earning from trade(constant 2005 US) in Chad in 1992 to that in 1997?
Your answer should be very brief. 0.82. What is the ratio of the Earning from trade(constant 2005 US) of Norway in 1992 to that in 1997?
Offer a terse response. 0.72. What is the ratio of the Earning from trade(constant 2005 US) of Sierra Leone in 1992 to that in 1997?
Make the answer very short. 1.82. What is the ratio of the Earning from trade(constant 2005 US) in Chad in 1993 to that in 1994?
Give a very brief answer. 1.1. What is the ratio of the Earning from trade(constant 2005 US) in Norway in 1993 to that in 1994?
Provide a succinct answer. 0.92. What is the ratio of the Earning from trade(constant 2005 US) of Sierra Leone in 1993 to that in 1994?
Keep it short and to the point. 1.31. What is the ratio of the Earning from trade(constant 2005 US) of Chad in 1993 to that in 1995?
Your answer should be very brief. 0.8. What is the ratio of the Earning from trade(constant 2005 US) of Norway in 1993 to that in 1995?
Offer a very short reply. 0.88. What is the ratio of the Earning from trade(constant 2005 US) of Sierra Leone in 1993 to that in 1995?
Make the answer very short. 2.05. What is the ratio of the Earning from trade(constant 2005 US) in Chad in 1993 to that in 1996?
Offer a very short reply. 0.98. What is the ratio of the Earning from trade(constant 2005 US) of Norway in 1993 to that in 1996?
Provide a succinct answer. 0.8. What is the ratio of the Earning from trade(constant 2005 US) of Sierra Leone in 1993 to that in 1996?
Your answer should be compact. 1.16. What is the ratio of the Earning from trade(constant 2005 US) of Chad in 1993 to that in 1997?
Provide a succinct answer. 0.87. What is the ratio of the Earning from trade(constant 2005 US) in Norway in 1993 to that in 1997?
Your answer should be very brief. 0.74. What is the ratio of the Earning from trade(constant 2005 US) in Sierra Leone in 1993 to that in 1997?
Offer a terse response. 1.57. What is the ratio of the Earning from trade(constant 2005 US) of Chad in 1994 to that in 1995?
Ensure brevity in your answer.  0.73. What is the ratio of the Earning from trade(constant 2005 US) in Sierra Leone in 1994 to that in 1995?
Your response must be concise. 1.57. What is the ratio of the Earning from trade(constant 2005 US) in Chad in 1994 to that in 1996?
Offer a terse response. 0.89. What is the ratio of the Earning from trade(constant 2005 US) in Norway in 1994 to that in 1996?
Your response must be concise. 0.87. What is the ratio of the Earning from trade(constant 2005 US) in Sierra Leone in 1994 to that in 1996?
Provide a succinct answer. 0.89. What is the ratio of the Earning from trade(constant 2005 US) in Chad in 1994 to that in 1997?
Provide a short and direct response. 0.79. What is the ratio of the Earning from trade(constant 2005 US) in Norway in 1994 to that in 1997?
Make the answer very short. 0.8. What is the ratio of the Earning from trade(constant 2005 US) in Sierra Leone in 1994 to that in 1997?
Keep it short and to the point. 1.2. What is the ratio of the Earning from trade(constant 2005 US) of Chad in 1995 to that in 1996?
Ensure brevity in your answer.  1.22. What is the ratio of the Earning from trade(constant 2005 US) of Norway in 1995 to that in 1996?
Provide a succinct answer. 0.91. What is the ratio of the Earning from trade(constant 2005 US) in Sierra Leone in 1995 to that in 1996?
Offer a terse response. 0.57. What is the ratio of the Earning from trade(constant 2005 US) of Chad in 1995 to that in 1997?
Provide a short and direct response. 1.09. What is the ratio of the Earning from trade(constant 2005 US) in Norway in 1995 to that in 1997?
Provide a succinct answer. 0.84. What is the ratio of the Earning from trade(constant 2005 US) of Sierra Leone in 1995 to that in 1997?
Ensure brevity in your answer.  0.77. What is the ratio of the Earning from trade(constant 2005 US) of Chad in 1996 to that in 1997?
Your response must be concise. 0.9. What is the ratio of the Earning from trade(constant 2005 US) in Norway in 1996 to that in 1997?
Your answer should be very brief. 0.93. What is the ratio of the Earning from trade(constant 2005 US) in Sierra Leone in 1996 to that in 1997?
Your answer should be compact. 1.35. What is the difference between the highest and the second highest Earning from trade(constant 2005 US) of Chad?
Offer a very short reply. 9.13e+07. What is the difference between the highest and the second highest Earning from trade(constant 2005 US) of Norway?
Provide a succinct answer. 8.57e+09. What is the difference between the highest and the second highest Earning from trade(constant 2005 US) in Sierra Leone?
Your answer should be compact. 1.12e+07. What is the difference between the highest and the lowest Earning from trade(constant 2005 US) of Chad?
Ensure brevity in your answer.  2.89e+08. What is the difference between the highest and the lowest Earning from trade(constant 2005 US) of Norway?
Keep it short and to the point. 4.21e+1. What is the difference between the highest and the lowest Earning from trade(constant 2005 US) of Sierra Leone?
Ensure brevity in your answer.  1.14e+08. 